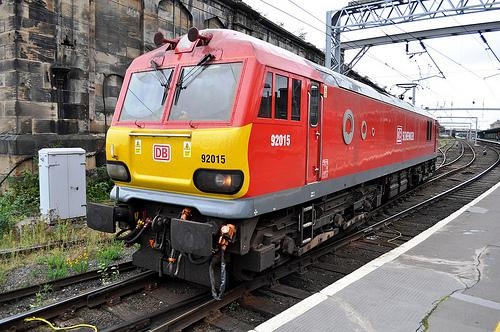Question: how many trains are there?
Choices:
A. Two.
B. Three.
C. Four.
D. One.
Answer with the letter. Answer: D 